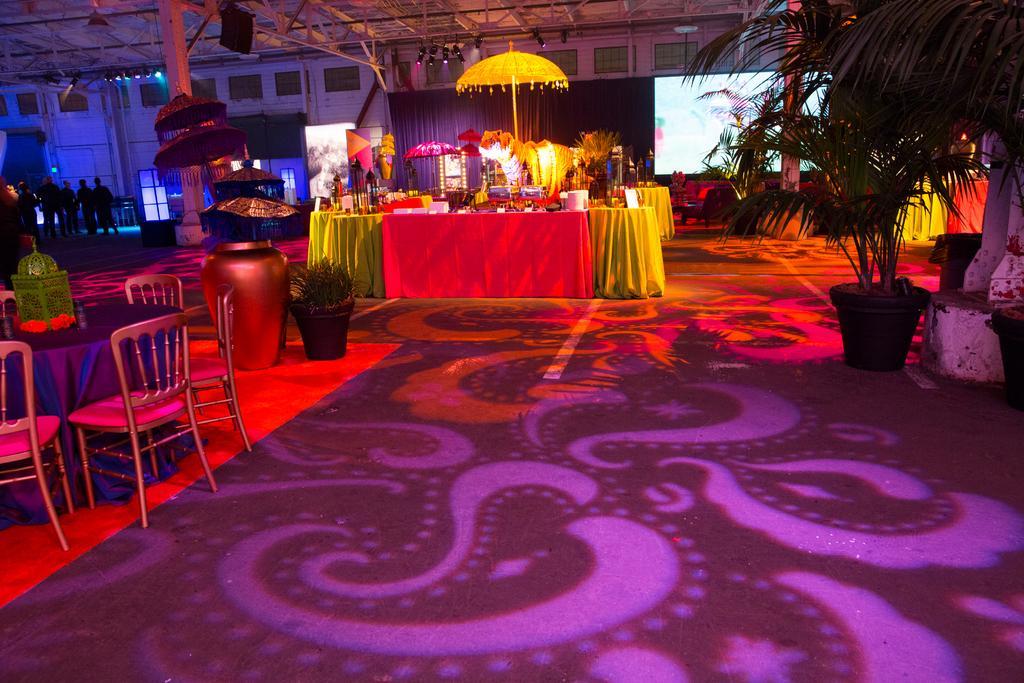Can you describe this image briefly? In this image, on the left side we can see a table and some chairs and we can see some plants, and on the left side we can see some people standing and in the middle we can see a set. 